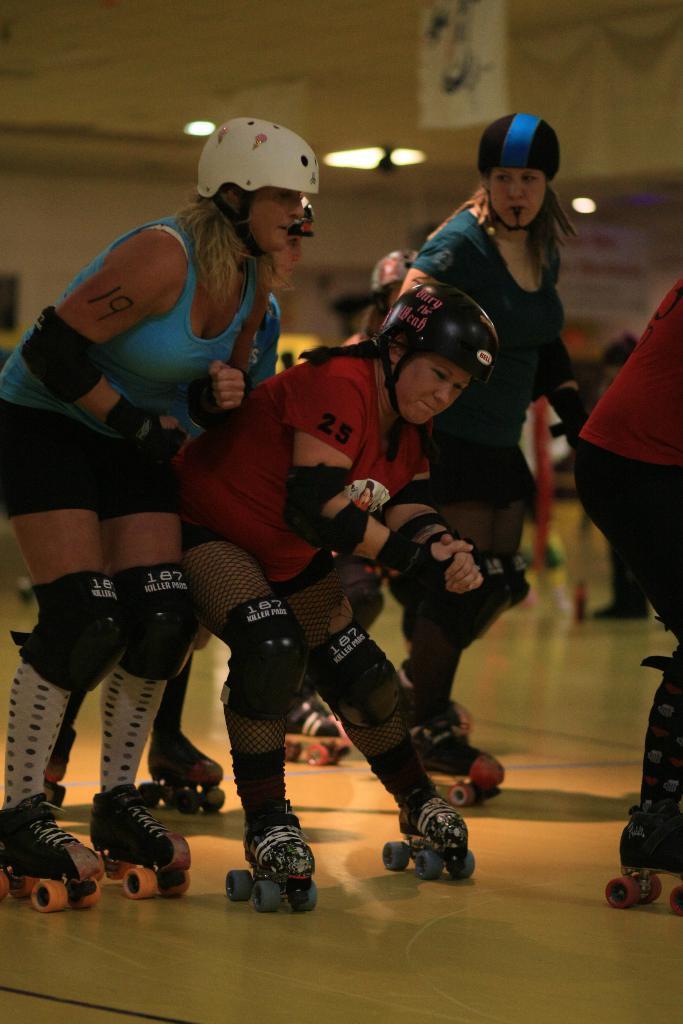How would you summarize this image in a sentence or two? In this picture we can see few people standing on a skateboard. We can see some lights and a board is visible in the background. 